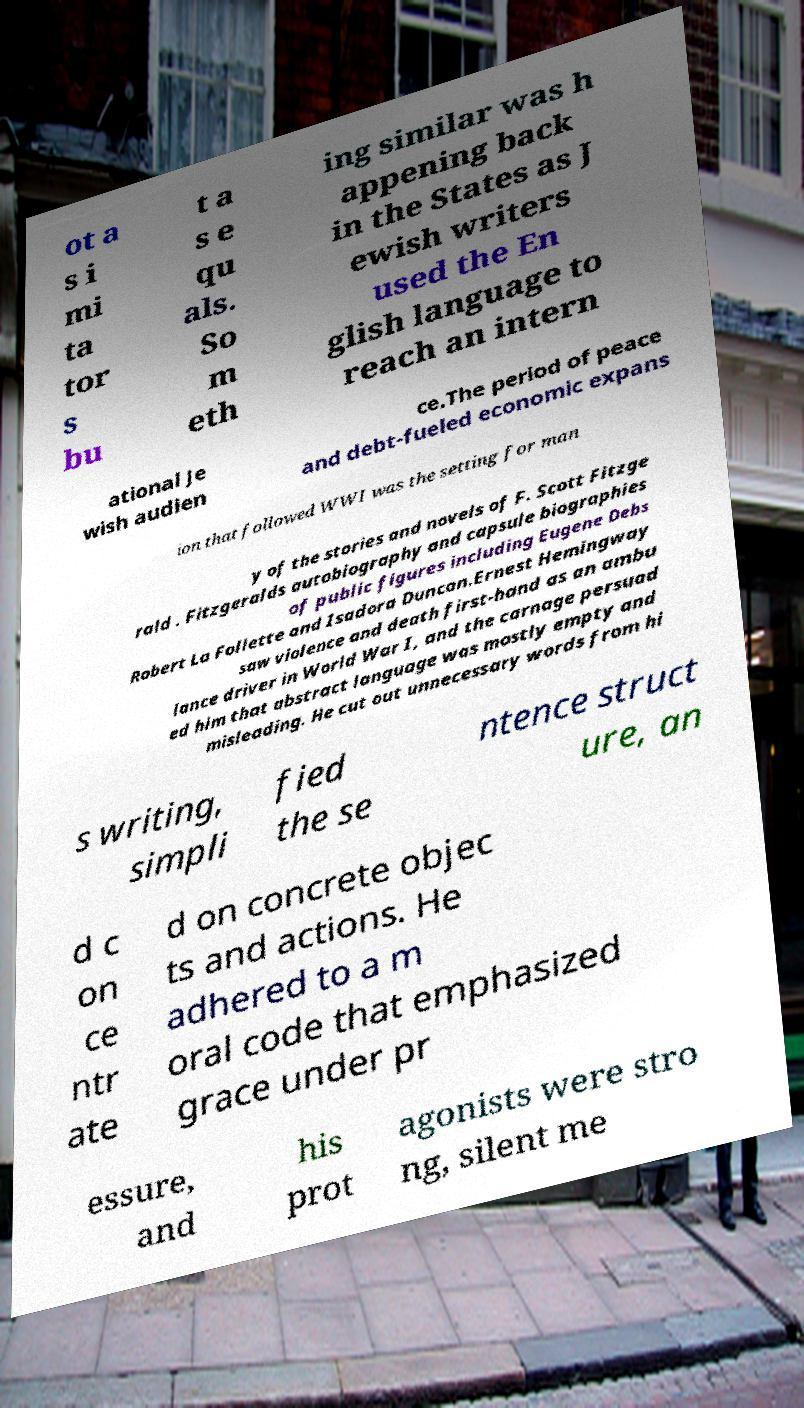What messages or text are displayed in this image? I need them in a readable, typed format. ot a s i mi ta tor s bu t a s e qu als. So m eth ing similar was h appening back in the States as J ewish writers used the En glish language to reach an intern ational Je wish audien ce.The period of peace and debt-fueled economic expans ion that followed WWI was the setting for man y of the stories and novels of F. Scott Fitzge rald . Fitzgeralds autobiography and capsule biographies of public figures including Eugene Debs Robert La Follette and Isadora Duncan.Ernest Hemingway saw violence and death first-hand as an ambu lance driver in World War I, and the carnage persuad ed him that abstract language was mostly empty and misleading. He cut out unnecessary words from hi s writing, simpli fied the se ntence struct ure, an d c on ce ntr ate d on concrete objec ts and actions. He adhered to a m oral code that emphasized grace under pr essure, and his prot agonists were stro ng, silent me 